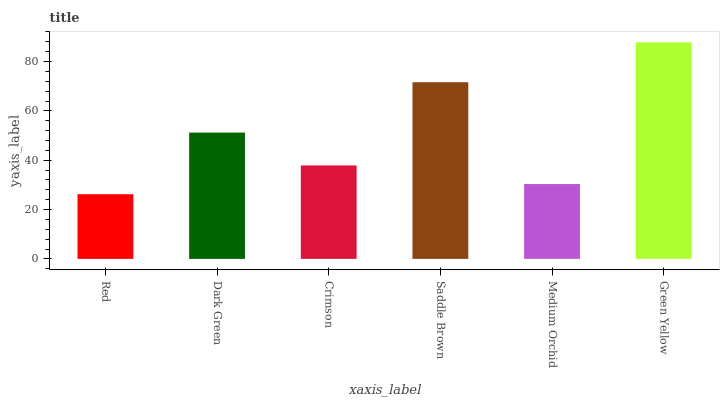Is Dark Green the minimum?
Answer yes or no. No. Is Dark Green the maximum?
Answer yes or no. No. Is Dark Green greater than Red?
Answer yes or no. Yes. Is Red less than Dark Green?
Answer yes or no. Yes. Is Red greater than Dark Green?
Answer yes or no. No. Is Dark Green less than Red?
Answer yes or no. No. Is Dark Green the high median?
Answer yes or no. Yes. Is Crimson the low median?
Answer yes or no. Yes. Is Medium Orchid the high median?
Answer yes or no. No. Is Red the low median?
Answer yes or no. No. 